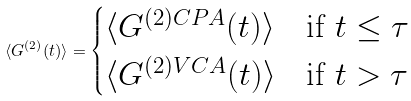Convert formula to latex. <formula><loc_0><loc_0><loc_500><loc_500>\langle G ^ { ( 2 ) } ( t ) \rangle = \begin{cases} \langle G ^ { ( 2 ) C P A } ( t ) \rangle & \text {if } t \leq \tau \\ \langle G ^ { ( 2 ) V C A } ( t ) \rangle & \text {if } t > \tau \end{cases}</formula> 